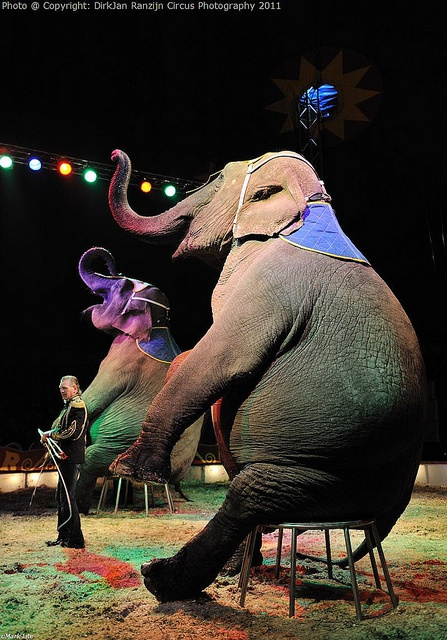Describe the objects in this image and their specific colors. I can see elephant in black, gray, tan, and darkgray tones, elephant in black, gray, and brown tones, and people in black, gray, tan, and maroon tones in this image. 